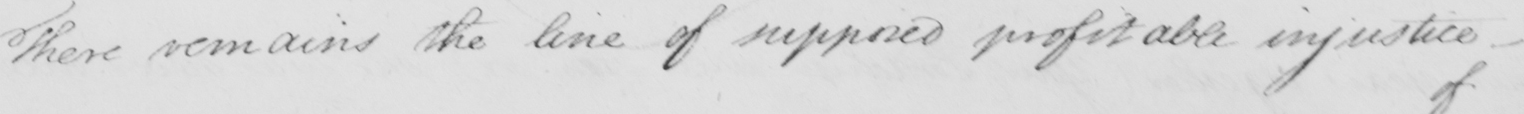What is written in this line of handwriting? There remains the line of supposed profitable injustice _ 